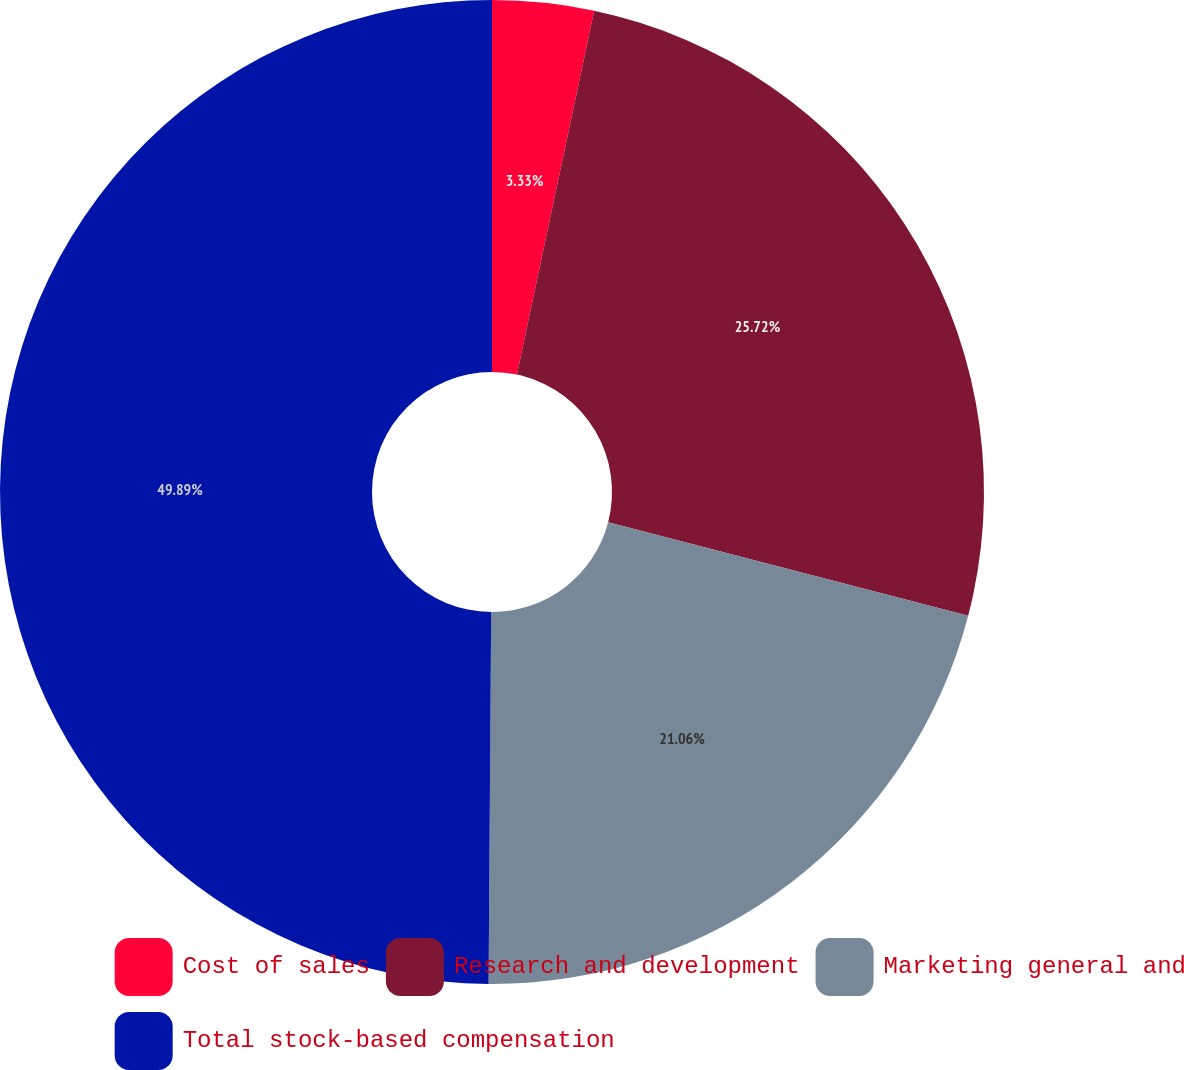Convert chart to OTSL. <chart><loc_0><loc_0><loc_500><loc_500><pie_chart><fcel>Cost of sales<fcel>Research and development<fcel>Marketing general and<fcel>Total stock-based compensation<nl><fcel>3.33%<fcel>25.72%<fcel>21.06%<fcel>49.89%<nl></chart> 